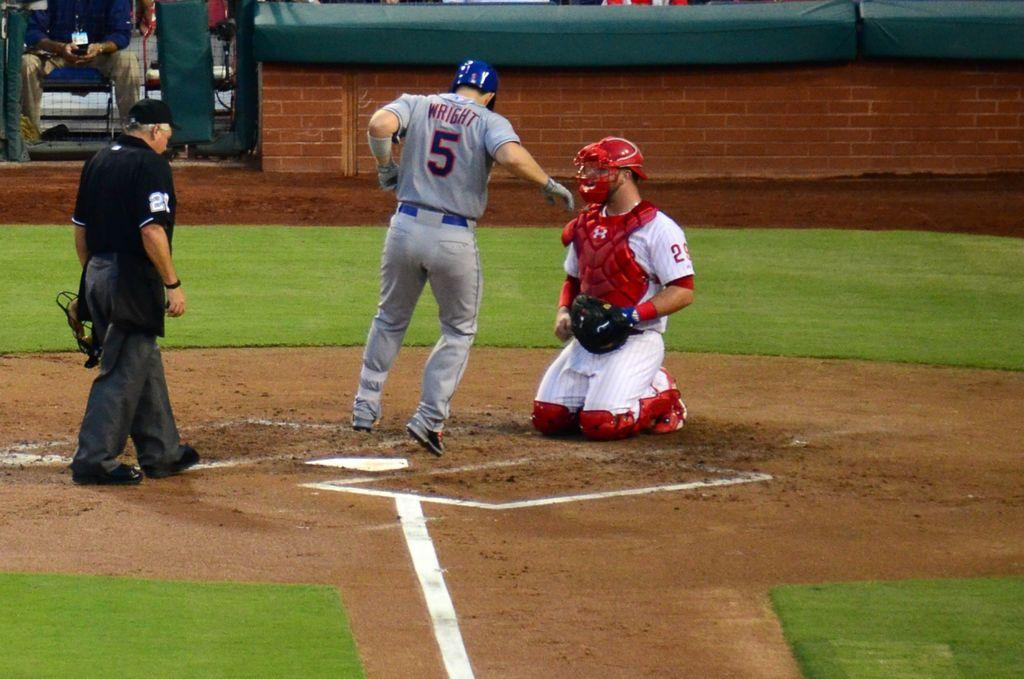<image>
Describe the image concisely. A man with the number five on his jersey runs near the catcher and umpire. 